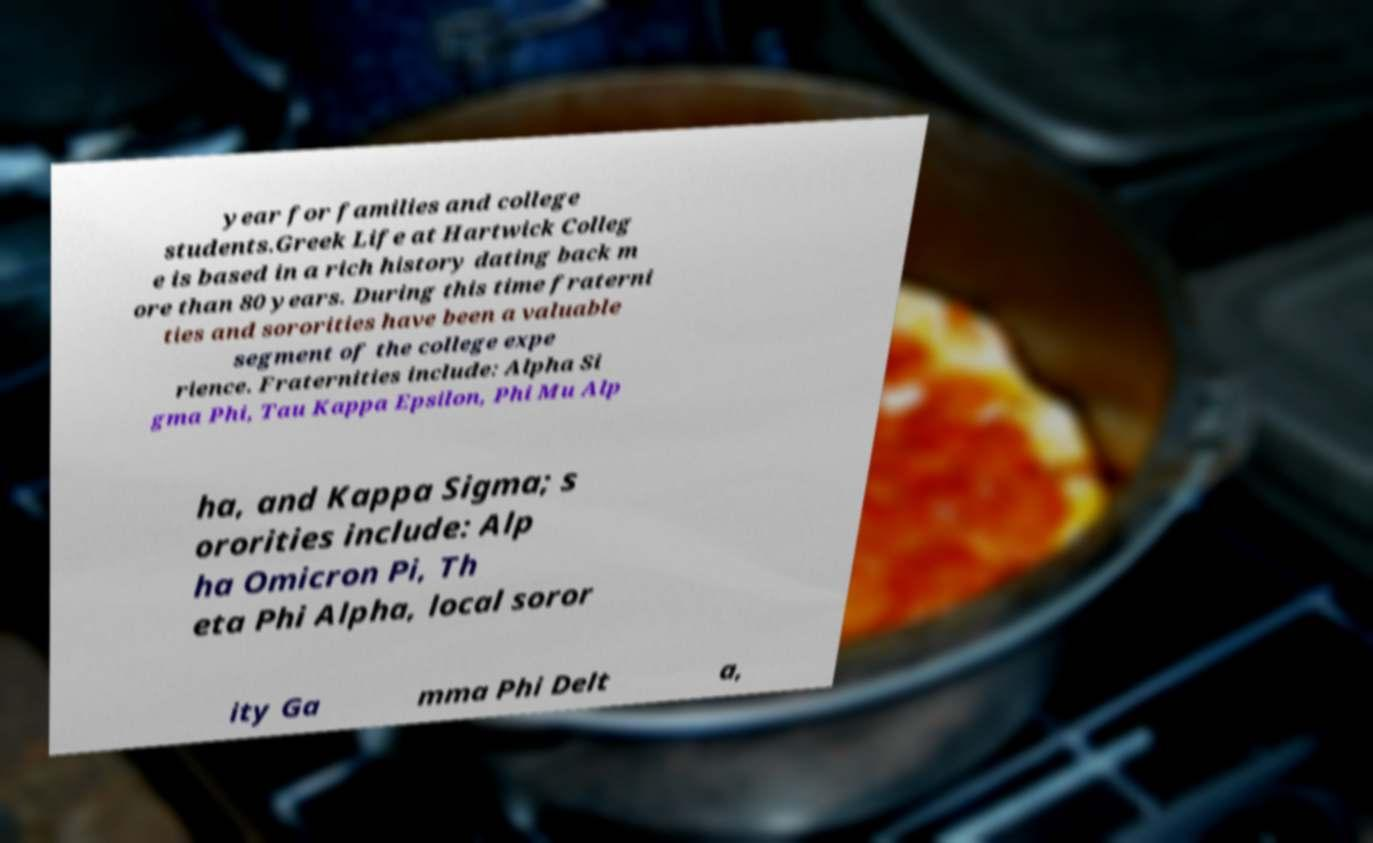Please read and relay the text visible in this image. What does it say? year for families and college students.Greek Life at Hartwick Colleg e is based in a rich history dating back m ore than 80 years. During this time fraterni ties and sororities have been a valuable segment of the college expe rience. Fraternities include: Alpha Si gma Phi, Tau Kappa Epsilon, Phi Mu Alp ha, and Kappa Sigma; s ororities include: Alp ha Omicron Pi, Th eta Phi Alpha, local soror ity Ga mma Phi Delt a, 